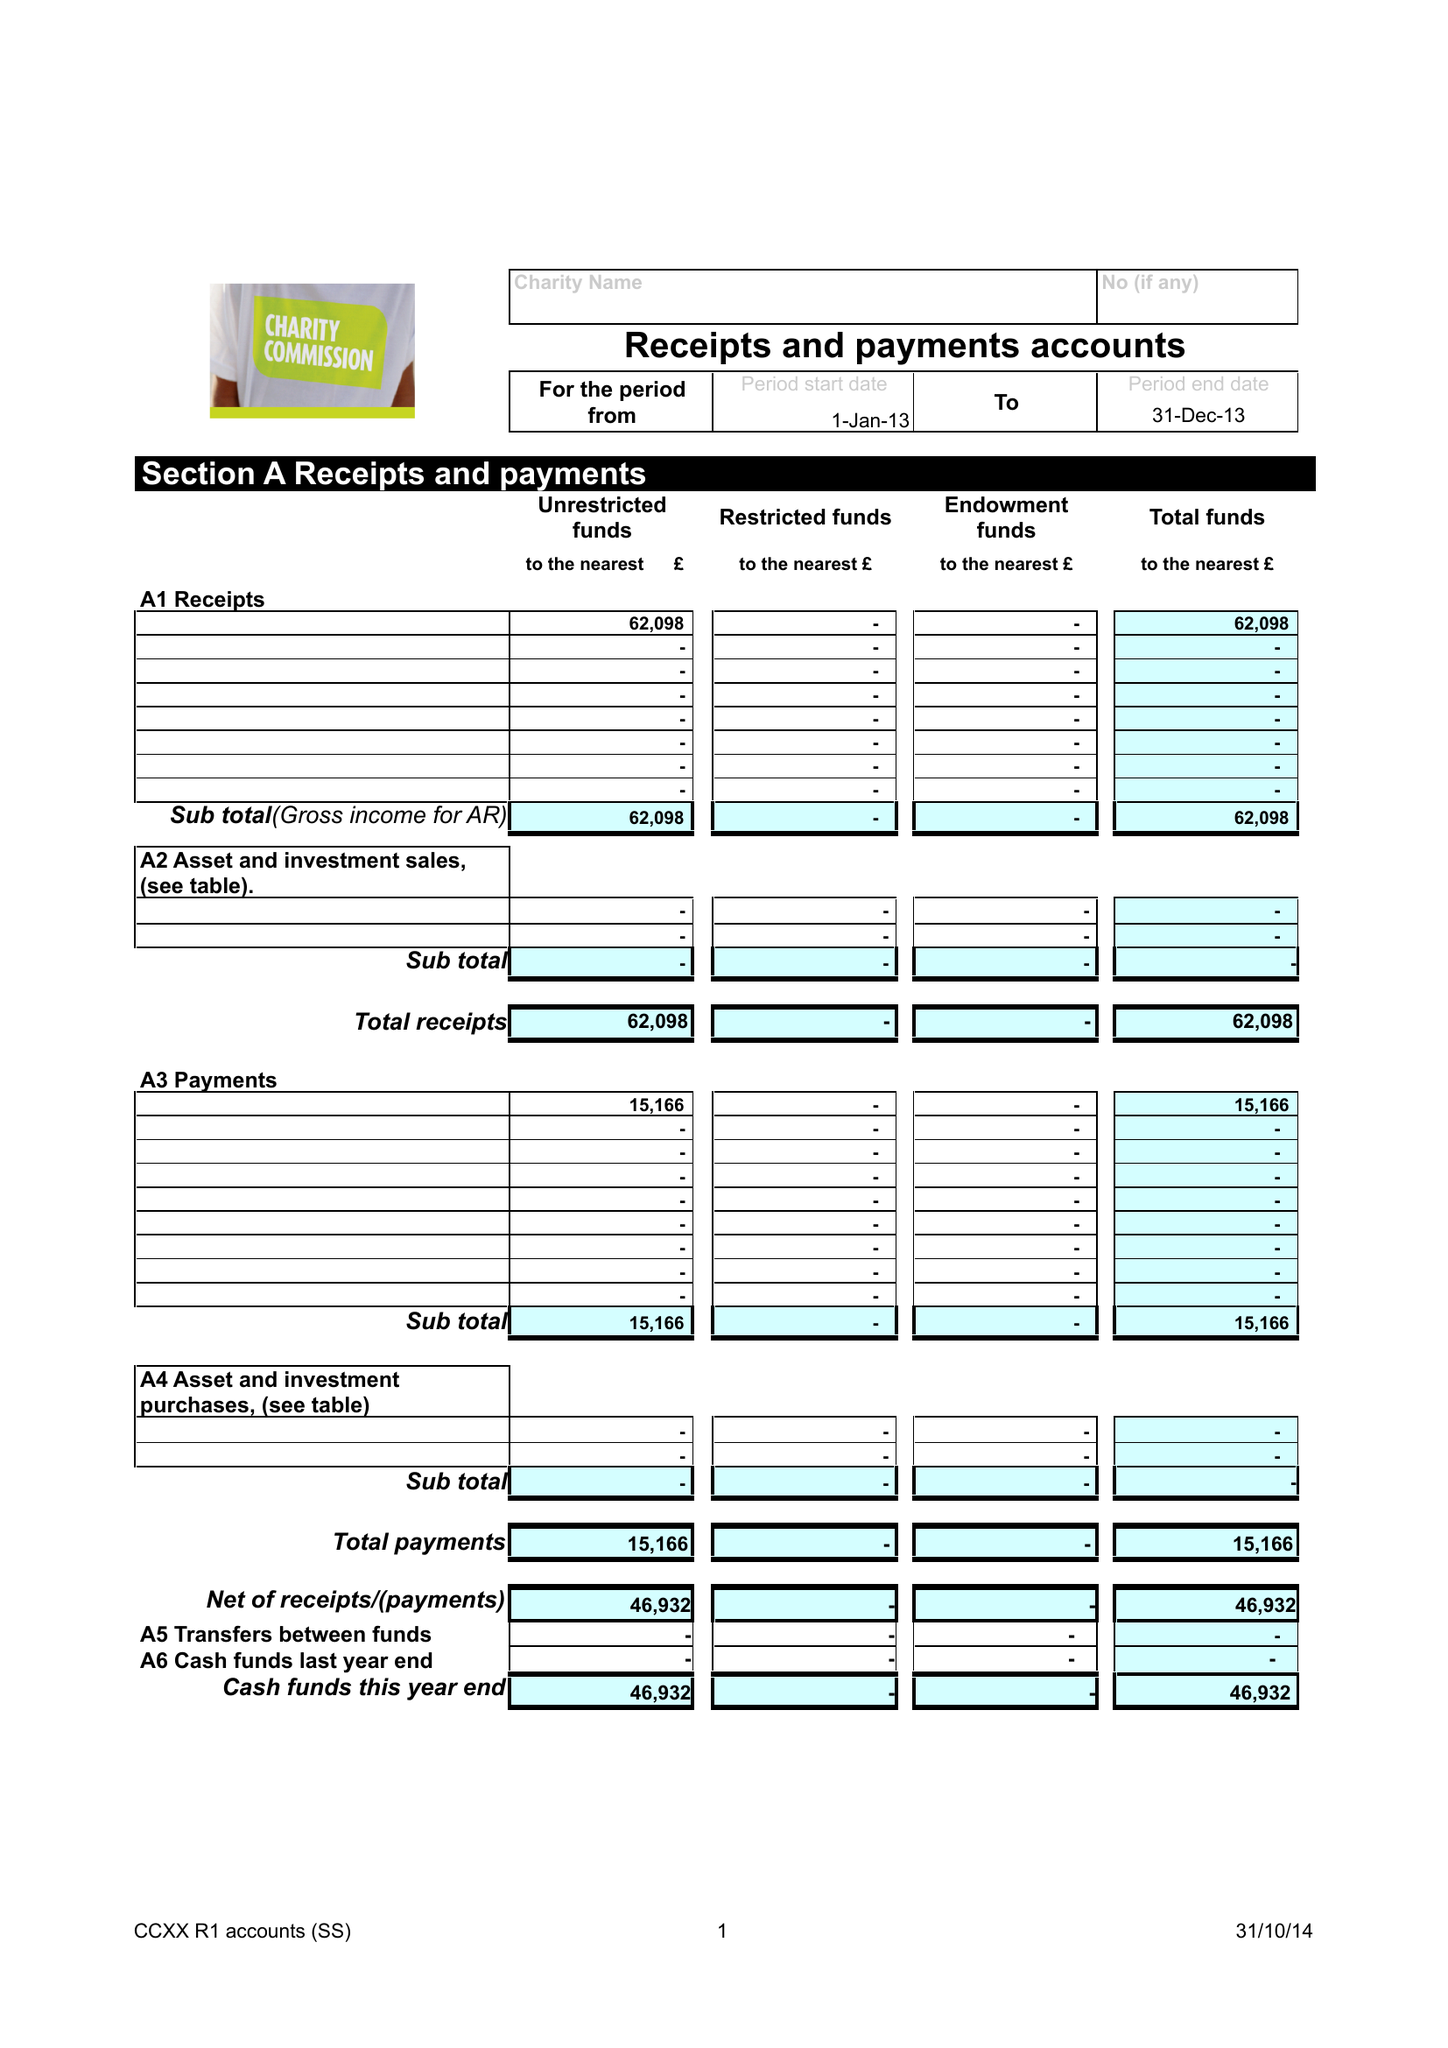What is the value for the report_date?
Answer the question using a single word or phrase. 2013-12-31 